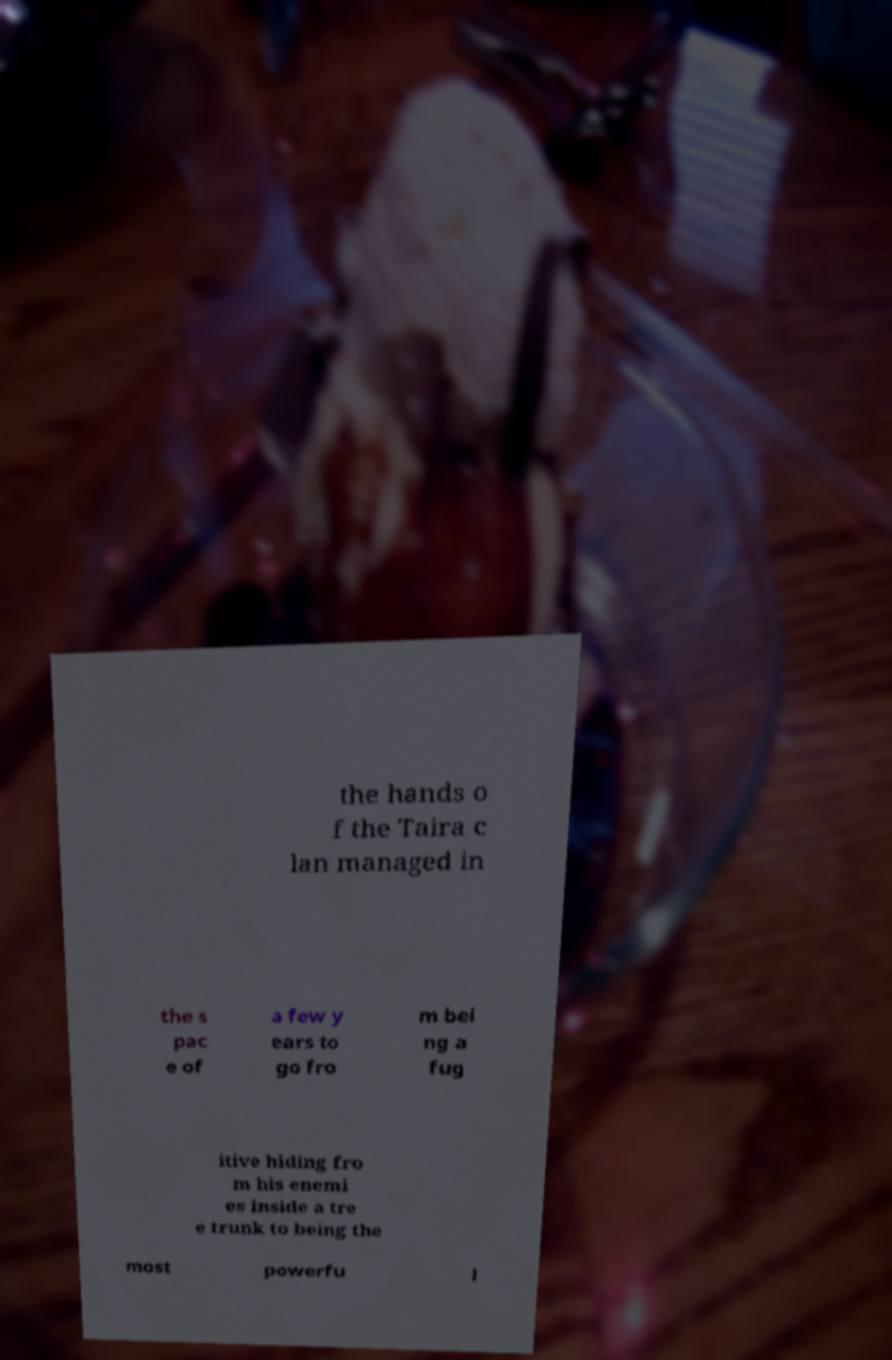I need the written content from this picture converted into text. Can you do that? the hands o f the Taira c lan managed in the s pac e of a few y ears to go fro m bei ng a fug itive hiding fro m his enemi es inside a tre e trunk to being the most powerfu l 